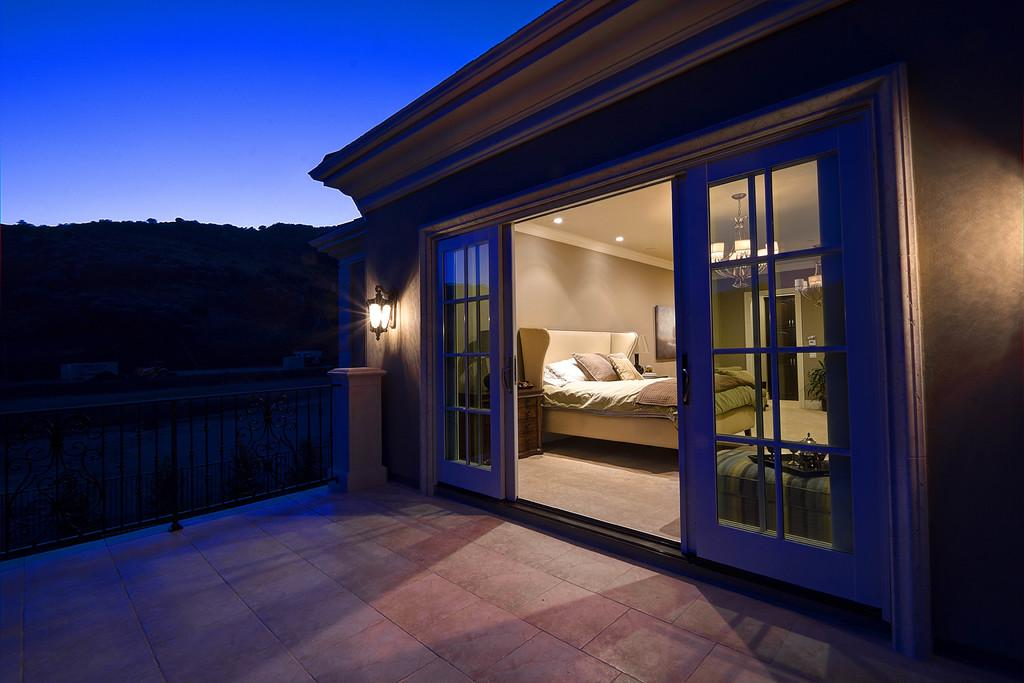What type of furniture is present in the room? There is a bed, a couch, and a table in the room. What architectural features can be seen in the room? There are pillars in the room. What decorative or functional item is present in the room? There is a plant and a frame in the room. What lighting is available in the room? There are lights in the room. How can one enter or exit the room? There is a door in the room. What is visible in the background of the scene? There is a fence, trees, and the sky visible in the background. What advice is given by the elbow in the image? There is no elbow present in the image, and therefore no advice can be given. What type of throat can be seen in the image? There is no throat present in the image. 